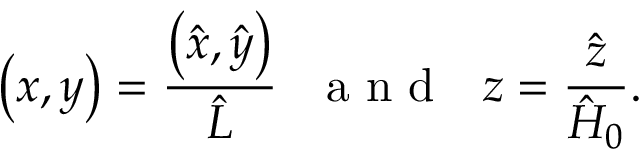<formula> <loc_0><loc_0><loc_500><loc_500>\left ( x , y \right ) = \frac { \left ( \hat { x } , \hat { y } \right ) } { \hat { L } } a n d z = \frac { \hat { z } } { \hat { H } _ { 0 } } .</formula> 